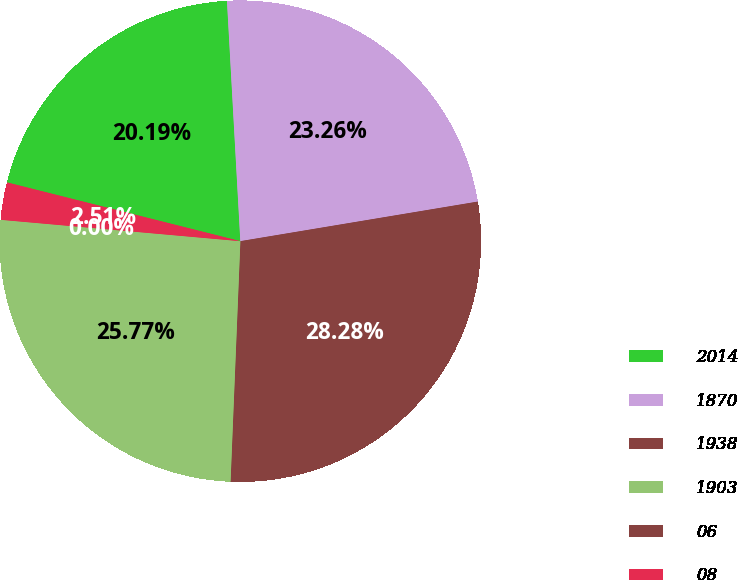Convert chart. <chart><loc_0><loc_0><loc_500><loc_500><pie_chart><fcel>2014<fcel>1870<fcel>1938<fcel>1903<fcel>06<fcel>08<nl><fcel>20.19%<fcel>23.26%<fcel>28.28%<fcel>25.77%<fcel>0.0%<fcel>2.51%<nl></chart> 